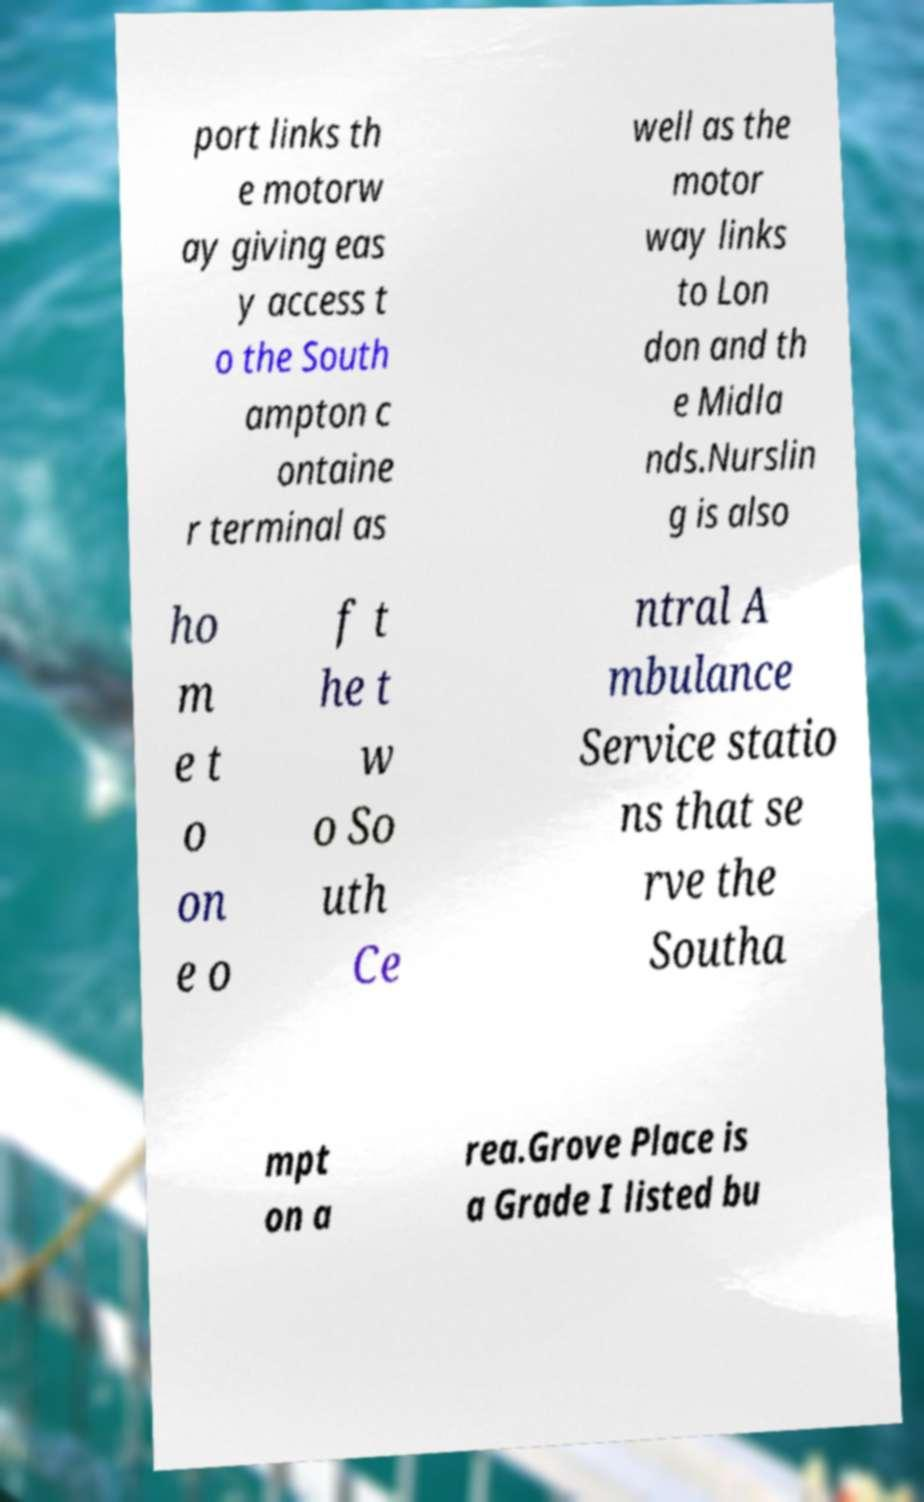For documentation purposes, I need the text within this image transcribed. Could you provide that? port links th e motorw ay giving eas y access t o the South ampton c ontaine r terminal as well as the motor way links to Lon don and th e Midla nds.Nurslin g is also ho m e t o on e o f t he t w o So uth Ce ntral A mbulance Service statio ns that se rve the Southa mpt on a rea.Grove Place is a Grade I listed bu 